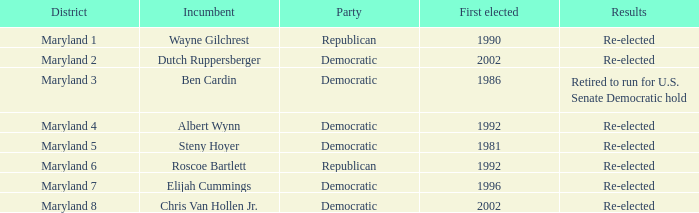What are the outcomes for the current officeholder who initially won the election in 1996? Re-elected. 